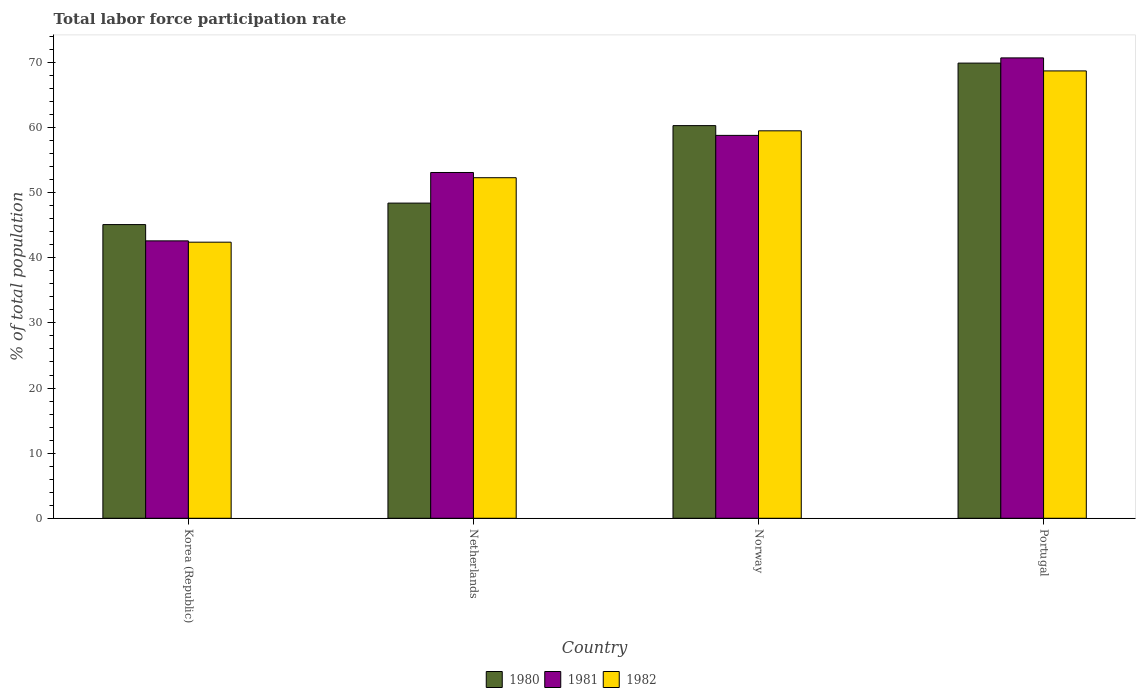How many different coloured bars are there?
Your answer should be compact. 3. How many groups of bars are there?
Ensure brevity in your answer.  4. Are the number of bars per tick equal to the number of legend labels?
Your answer should be compact. Yes. Are the number of bars on each tick of the X-axis equal?
Ensure brevity in your answer.  Yes. How many bars are there on the 3rd tick from the left?
Your response must be concise. 3. What is the label of the 3rd group of bars from the left?
Ensure brevity in your answer.  Norway. In how many cases, is the number of bars for a given country not equal to the number of legend labels?
Keep it short and to the point. 0. What is the total labor force participation rate in 1982 in Korea (Republic)?
Give a very brief answer. 42.4. Across all countries, what is the maximum total labor force participation rate in 1980?
Ensure brevity in your answer.  69.9. Across all countries, what is the minimum total labor force participation rate in 1982?
Ensure brevity in your answer.  42.4. In which country was the total labor force participation rate in 1982 maximum?
Provide a short and direct response. Portugal. What is the total total labor force participation rate in 1980 in the graph?
Ensure brevity in your answer.  223.7. What is the difference between the total labor force participation rate in 1980 in Korea (Republic) and that in Netherlands?
Offer a terse response. -3.3. What is the difference between the total labor force participation rate in 1982 in Portugal and the total labor force participation rate in 1981 in Netherlands?
Your response must be concise. 15.6. What is the average total labor force participation rate in 1981 per country?
Your response must be concise. 56.3. What is the difference between the total labor force participation rate of/in 1980 and total labor force participation rate of/in 1981 in Portugal?
Make the answer very short. -0.8. What is the ratio of the total labor force participation rate in 1982 in Korea (Republic) to that in Norway?
Offer a very short reply. 0.71. What is the difference between the highest and the second highest total labor force participation rate in 1982?
Your answer should be very brief. -9.2. What is the difference between the highest and the lowest total labor force participation rate in 1981?
Your answer should be very brief. 28.1. In how many countries, is the total labor force participation rate in 1980 greater than the average total labor force participation rate in 1980 taken over all countries?
Your answer should be compact. 2. Is the sum of the total labor force participation rate in 1980 in Netherlands and Norway greater than the maximum total labor force participation rate in 1982 across all countries?
Provide a short and direct response. Yes. What does the 1st bar from the left in Netherlands represents?
Ensure brevity in your answer.  1980. What does the 2nd bar from the right in Netherlands represents?
Give a very brief answer. 1981. Are all the bars in the graph horizontal?
Ensure brevity in your answer.  No. How many countries are there in the graph?
Provide a short and direct response. 4. Does the graph contain grids?
Make the answer very short. No. What is the title of the graph?
Offer a terse response. Total labor force participation rate. What is the label or title of the Y-axis?
Offer a terse response. % of total population. What is the % of total population of 1980 in Korea (Republic)?
Provide a short and direct response. 45.1. What is the % of total population in 1981 in Korea (Republic)?
Your response must be concise. 42.6. What is the % of total population of 1982 in Korea (Republic)?
Keep it short and to the point. 42.4. What is the % of total population of 1980 in Netherlands?
Provide a succinct answer. 48.4. What is the % of total population of 1981 in Netherlands?
Your answer should be very brief. 53.1. What is the % of total population of 1982 in Netherlands?
Your response must be concise. 52.3. What is the % of total population of 1980 in Norway?
Your response must be concise. 60.3. What is the % of total population in 1981 in Norway?
Ensure brevity in your answer.  58.8. What is the % of total population of 1982 in Norway?
Keep it short and to the point. 59.5. What is the % of total population of 1980 in Portugal?
Make the answer very short. 69.9. What is the % of total population of 1981 in Portugal?
Offer a terse response. 70.7. What is the % of total population in 1982 in Portugal?
Keep it short and to the point. 68.7. Across all countries, what is the maximum % of total population in 1980?
Your answer should be compact. 69.9. Across all countries, what is the maximum % of total population in 1981?
Give a very brief answer. 70.7. Across all countries, what is the maximum % of total population of 1982?
Make the answer very short. 68.7. Across all countries, what is the minimum % of total population of 1980?
Make the answer very short. 45.1. Across all countries, what is the minimum % of total population in 1981?
Ensure brevity in your answer.  42.6. Across all countries, what is the minimum % of total population of 1982?
Give a very brief answer. 42.4. What is the total % of total population in 1980 in the graph?
Provide a short and direct response. 223.7. What is the total % of total population in 1981 in the graph?
Offer a terse response. 225.2. What is the total % of total population in 1982 in the graph?
Make the answer very short. 222.9. What is the difference between the % of total population of 1980 in Korea (Republic) and that in Netherlands?
Make the answer very short. -3.3. What is the difference between the % of total population of 1981 in Korea (Republic) and that in Netherlands?
Provide a short and direct response. -10.5. What is the difference between the % of total population in 1982 in Korea (Republic) and that in Netherlands?
Offer a terse response. -9.9. What is the difference between the % of total population in 1980 in Korea (Republic) and that in Norway?
Provide a short and direct response. -15.2. What is the difference between the % of total population in 1981 in Korea (Republic) and that in Norway?
Give a very brief answer. -16.2. What is the difference between the % of total population in 1982 in Korea (Republic) and that in Norway?
Your response must be concise. -17.1. What is the difference between the % of total population in 1980 in Korea (Republic) and that in Portugal?
Give a very brief answer. -24.8. What is the difference between the % of total population in 1981 in Korea (Republic) and that in Portugal?
Offer a terse response. -28.1. What is the difference between the % of total population in 1982 in Korea (Republic) and that in Portugal?
Your answer should be compact. -26.3. What is the difference between the % of total population in 1980 in Netherlands and that in Norway?
Provide a succinct answer. -11.9. What is the difference between the % of total population in 1981 in Netherlands and that in Norway?
Ensure brevity in your answer.  -5.7. What is the difference between the % of total population of 1980 in Netherlands and that in Portugal?
Provide a succinct answer. -21.5. What is the difference between the % of total population of 1981 in Netherlands and that in Portugal?
Ensure brevity in your answer.  -17.6. What is the difference between the % of total population in 1982 in Netherlands and that in Portugal?
Provide a short and direct response. -16.4. What is the difference between the % of total population in 1981 in Norway and that in Portugal?
Keep it short and to the point. -11.9. What is the difference between the % of total population in 1980 in Korea (Republic) and the % of total population in 1981 in Netherlands?
Give a very brief answer. -8. What is the difference between the % of total population in 1980 in Korea (Republic) and the % of total population in 1981 in Norway?
Your answer should be compact. -13.7. What is the difference between the % of total population of 1980 in Korea (Republic) and the % of total population of 1982 in Norway?
Give a very brief answer. -14.4. What is the difference between the % of total population in 1981 in Korea (Republic) and the % of total population in 1982 in Norway?
Keep it short and to the point. -16.9. What is the difference between the % of total population in 1980 in Korea (Republic) and the % of total population in 1981 in Portugal?
Offer a very short reply. -25.6. What is the difference between the % of total population of 1980 in Korea (Republic) and the % of total population of 1982 in Portugal?
Keep it short and to the point. -23.6. What is the difference between the % of total population in 1981 in Korea (Republic) and the % of total population in 1982 in Portugal?
Provide a succinct answer. -26.1. What is the difference between the % of total population of 1980 in Netherlands and the % of total population of 1981 in Norway?
Make the answer very short. -10.4. What is the difference between the % of total population in 1980 in Netherlands and the % of total population in 1981 in Portugal?
Your response must be concise. -22.3. What is the difference between the % of total population of 1980 in Netherlands and the % of total population of 1982 in Portugal?
Your answer should be very brief. -20.3. What is the difference between the % of total population of 1981 in Netherlands and the % of total population of 1982 in Portugal?
Your answer should be very brief. -15.6. What is the difference between the % of total population in 1980 in Norway and the % of total population in 1981 in Portugal?
Give a very brief answer. -10.4. What is the difference between the % of total population of 1981 in Norway and the % of total population of 1982 in Portugal?
Offer a very short reply. -9.9. What is the average % of total population of 1980 per country?
Give a very brief answer. 55.92. What is the average % of total population in 1981 per country?
Provide a short and direct response. 56.3. What is the average % of total population of 1982 per country?
Offer a terse response. 55.73. What is the difference between the % of total population of 1981 and % of total population of 1982 in Korea (Republic)?
Your answer should be very brief. 0.2. What is the difference between the % of total population in 1980 and % of total population in 1981 in Netherlands?
Make the answer very short. -4.7. What is the difference between the % of total population of 1980 and % of total population of 1982 in Netherlands?
Your answer should be very brief. -3.9. What is the difference between the % of total population in 1981 and % of total population in 1982 in Netherlands?
Provide a short and direct response. 0.8. What is the difference between the % of total population of 1980 and % of total population of 1981 in Norway?
Offer a very short reply. 1.5. What is the difference between the % of total population in 1980 and % of total population in 1981 in Portugal?
Provide a succinct answer. -0.8. What is the ratio of the % of total population in 1980 in Korea (Republic) to that in Netherlands?
Make the answer very short. 0.93. What is the ratio of the % of total population of 1981 in Korea (Republic) to that in Netherlands?
Make the answer very short. 0.8. What is the ratio of the % of total population in 1982 in Korea (Republic) to that in Netherlands?
Ensure brevity in your answer.  0.81. What is the ratio of the % of total population in 1980 in Korea (Republic) to that in Norway?
Make the answer very short. 0.75. What is the ratio of the % of total population of 1981 in Korea (Republic) to that in Norway?
Your answer should be compact. 0.72. What is the ratio of the % of total population of 1982 in Korea (Republic) to that in Norway?
Ensure brevity in your answer.  0.71. What is the ratio of the % of total population in 1980 in Korea (Republic) to that in Portugal?
Provide a succinct answer. 0.65. What is the ratio of the % of total population in 1981 in Korea (Republic) to that in Portugal?
Offer a terse response. 0.6. What is the ratio of the % of total population in 1982 in Korea (Republic) to that in Portugal?
Give a very brief answer. 0.62. What is the ratio of the % of total population in 1980 in Netherlands to that in Norway?
Keep it short and to the point. 0.8. What is the ratio of the % of total population of 1981 in Netherlands to that in Norway?
Offer a terse response. 0.9. What is the ratio of the % of total population in 1982 in Netherlands to that in Norway?
Make the answer very short. 0.88. What is the ratio of the % of total population of 1980 in Netherlands to that in Portugal?
Give a very brief answer. 0.69. What is the ratio of the % of total population of 1981 in Netherlands to that in Portugal?
Your answer should be compact. 0.75. What is the ratio of the % of total population in 1982 in Netherlands to that in Portugal?
Give a very brief answer. 0.76. What is the ratio of the % of total population in 1980 in Norway to that in Portugal?
Keep it short and to the point. 0.86. What is the ratio of the % of total population of 1981 in Norway to that in Portugal?
Offer a terse response. 0.83. What is the ratio of the % of total population in 1982 in Norway to that in Portugal?
Provide a short and direct response. 0.87. What is the difference between the highest and the second highest % of total population in 1982?
Your answer should be very brief. 9.2. What is the difference between the highest and the lowest % of total population of 1980?
Ensure brevity in your answer.  24.8. What is the difference between the highest and the lowest % of total population in 1981?
Your response must be concise. 28.1. What is the difference between the highest and the lowest % of total population in 1982?
Offer a very short reply. 26.3. 